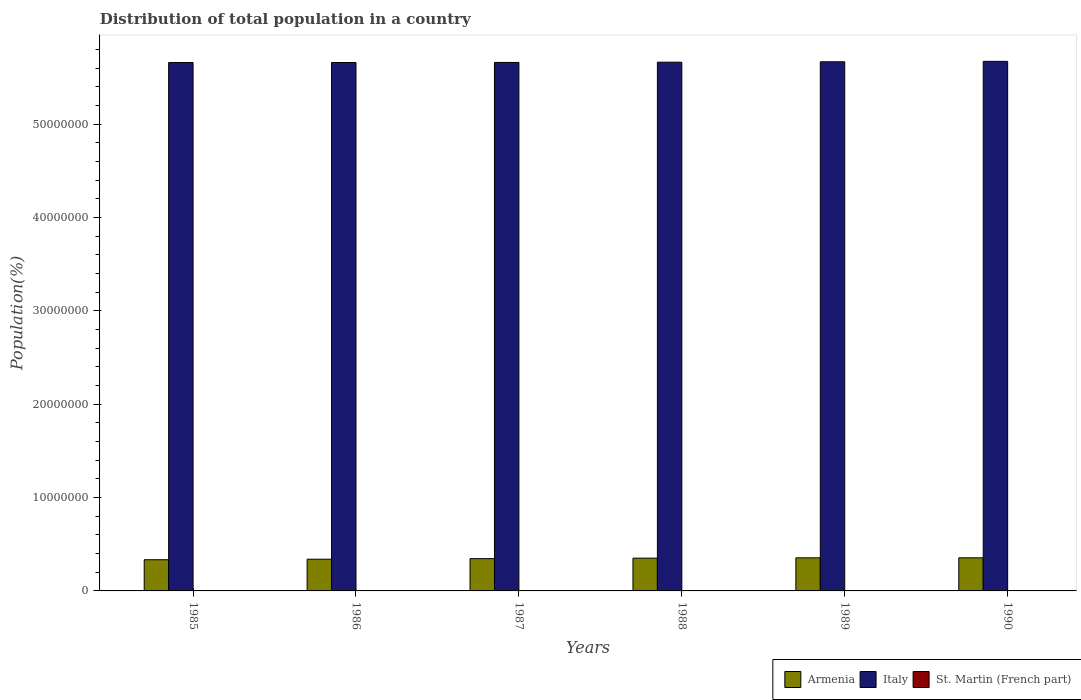How many bars are there on the 3rd tick from the left?
Provide a short and direct response. 3. What is the population of in Italy in 1987?
Ensure brevity in your answer.  5.66e+07. Across all years, what is the maximum population of in St. Martin (French part)?
Give a very brief answer. 3.00e+04. Across all years, what is the minimum population of in Italy?
Make the answer very short. 5.66e+07. What is the total population of in Italy in the graph?
Give a very brief answer. 3.40e+08. What is the difference between the population of in Italy in 1986 and that in 1990?
Provide a short and direct response. -1.23e+05. What is the difference between the population of in St. Martin (French part) in 1988 and the population of in Armenia in 1990?
Provide a short and direct response. -3.52e+06. What is the average population of in St. Martin (French part) per year?
Offer a very short reply. 2.30e+04. In the year 1990, what is the difference between the population of in Italy and population of in St. Martin (French part)?
Keep it short and to the point. 5.67e+07. What is the ratio of the population of in Italy in 1985 to that in 1986?
Make the answer very short. 1. Is the difference between the population of in Italy in 1985 and 1989 greater than the difference between the population of in St. Martin (French part) in 1985 and 1989?
Give a very brief answer. No. What is the difference between the highest and the second highest population of in St. Martin (French part)?
Your answer should be very brief. 2360. What is the difference between the highest and the lowest population of in St. Martin (French part)?
Your answer should be compact. 1.46e+04. Is the sum of the population of in Armenia in 1988 and 1989 greater than the maximum population of in Italy across all years?
Your answer should be very brief. No. What does the 3rd bar from the left in 1985 represents?
Your answer should be compact. St. Martin (French part). What does the 1st bar from the right in 1988 represents?
Your response must be concise. St. Martin (French part). Is it the case that in every year, the sum of the population of in Armenia and population of in Italy is greater than the population of in St. Martin (French part)?
Offer a very short reply. Yes. How many bars are there?
Give a very brief answer. 18. Are all the bars in the graph horizontal?
Provide a succinct answer. No. What is the difference between two consecutive major ticks on the Y-axis?
Keep it short and to the point. 1.00e+07. How many legend labels are there?
Provide a succinct answer. 3. What is the title of the graph?
Your response must be concise. Distribution of total population in a country. What is the label or title of the Y-axis?
Your answer should be very brief. Population(%). What is the Population(%) of Armenia in 1985?
Provide a short and direct response. 3.34e+06. What is the Population(%) in Italy in 1985?
Keep it short and to the point. 5.66e+07. What is the Population(%) of St. Martin (French part) in 1985?
Ensure brevity in your answer.  1.54e+04. What is the Population(%) in Armenia in 1986?
Provide a short and direct response. 3.40e+06. What is the Population(%) of Italy in 1986?
Keep it short and to the point. 5.66e+07. What is the Population(%) of St. Martin (French part) in 1986?
Offer a terse response. 1.83e+04. What is the Population(%) in Armenia in 1987?
Keep it short and to the point. 3.46e+06. What is the Population(%) in Italy in 1987?
Keep it short and to the point. 5.66e+07. What is the Population(%) of St. Martin (French part) in 1987?
Make the answer very short. 2.16e+04. What is the Population(%) of Armenia in 1988?
Your answer should be compact. 3.51e+06. What is the Population(%) of Italy in 1988?
Provide a short and direct response. 5.66e+07. What is the Population(%) of St. Martin (French part) in 1988?
Provide a succinct answer. 2.49e+04. What is the Population(%) of Armenia in 1989?
Offer a terse response. 3.54e+06. What is the Population(%) in Italy in 1989?
Your answer should be compact. 5.67e+07. What is the Population(%) of St. Martin (French part) in 1989?
Give a very brief answer. 2.77e+04. What is the Population(%) of Armenia in 1990?
Offer a very short reply. 3.54e+06. What is the Population(%) of Italy in 1990?
Offer a very short reply. 5.67e+07. What is the Population(%) of St. Martin (French part) in 1990?
Your answer should be very brief. 3.00e+04. Across all years, what is the maximum Population(%) in Armenia?
Give a very brief answer. 3.54e+06. Across all years, what is the maximum Population(%) in Italy?
Your response must be concise. 5.67e+07. Across all years, what is the maximum Population(%) in St. Martin (French part)?
Give a very brief answer. 3.00e+04. Across all years, what is the minimum Population(%) of Armenia?
Your answer should be very brief. 3.34e+06. Across all years, what is the minimum Population(%) in Italy?
Your answer should be compact. 5.66e+07. Across all years, what is the minimum Population(%) in St. Martin (French part)?
Your answer should be compact. 1.54e+04. What is the total Population(%) of Armenia in the graph?
Keep it short and to the point. 2.08e+07. What is the total Population(%) of Italy in the graph?
Offer a terse response. 3.40e+08. What is the total Population(%) in St. Martin (French part) in the graph?
Ensure brevity in your answer.  1.38e+05. What is the difference between the Population(%) in Armenia in 1985 and that in 1986?
Keep it short and to the point. -5.74e+04. What is the difference between the Population(%) of Italy in 1985 and that in 1986?
Offer a very short reply. -3084. What is the difference between the Population(%) in St. Martin (French part) in 1985 and that in 1986?
Your response must be concise. -2945. What is the difference between the Population(%) of Armenia in 1985 and that in 1987?
Offer a very short reply. -1.18e+05. What is the difference between the Population(%) of Italy in 1985 and that in 1987?
Give a very brief answer. -8860. What is the difference between the Population(%) of St. Martin (French part) in 1985 and that in 1987?
Offer a very short reply. -6236. What is the difference between the Population(%) of Armenia in 1985 and that in 1988?
Provide a succinct answer. -1.71e+05. What is the difference between the Population(%) in Italy in 1985 and that in 1988?
Ensure brevity in your answer.  -3.62e+04. What is the difference between the Population(%) in St. Martin (French part) in 1985 and that in 1988?
Your response must be concise. -9481. What is the difference between the Population(%) in Armenia in 1985 and that in 1989?
Ensure brevity in your answer.  -2.04e+05. What is the difference between the Population(%) of Italy in 1985 and that in 1989?
Offer a very short reply. -7.87e+04. What is the difference between the Population(%) of St. Martin (French part) in 1985 and that in 1989?
Your answer should be very brief. -1.23e+04. What is the difference between the Population(%) of Armenia in 1985 and that in 1990?
Your response must be concise. -2.06e+05. What is the difference between the Population(%) in Italy in 1985 and that in 1990?
Offer a terse response. -1.26e+05. What is the difference between the Population(%) in St. Martin (French part) in 1985 and that in 1990?
Offer a very short reply. -1.46e+04. What is the difference between the Population(%) in Armenia in 1986 and that in 1987?
Offer a very short reply. -6.05e+04. What is the difference between the Population(%) in Italy in 1986 and that in 1987?
Provide a short and direct response. -5776. What is the difference between the Population(%) of St. Martin (French part) in 1986 and that in 1987?
Your answer should be compact. -3291. What is the difference between the Population(%) of Armenia in 1986 and that in 1988?
Your answer should be very brief. -1.14e+05. What is the difference between the Population(%) in Italy in 1986 and that in 1988?
Offer a terse response. -3.31e+04. What is the difference between the Population(%) in St. Martin (French part) in 1986 and that in 1988?
Your answer should be compact. -6536. What is the difference between the Population(%) of Armenia in 1986 and that in 1989?
Your answer should be compact. -1.46e+05. What is the difference between the Population(%) in Italy in 1986 and that in 1989?
Give a very brief answer. -7.56e+04. What is the difference between the Population(%) in St. Martin (French part) in 1986 and that in 1989?
Offer a terse response. -9339. What is the difference between the Population(%) of Armenia in 1986 and that in 1990?
Provide a succinct answer. -1.48e+05. What is the difference between the Population(%) of Italy in 1986 and that in 1990?
Ensure brevity in your answer.  -1.23e+05. What is the difference between the Population(%) in St. Martin (French part) in 1986 and that in 1990?
Offer a very short reply. -1.17e+04. What is the difference between the Population(%) of Armenia in 1987 and that in 1988?
Offer a terse response. -5.34e+04. What is the difference between the Population(%) of Italy in 1987 and that in 1988?
Your response must be concise. -2.74e+04. What is the difference between the Population(%) in St. Martin (French part) in 1987 and that in 1988?
Your answer should be compact. -3245. What is the difference between the Population(%) of Armenia in 1987 and that in 1989?
Your response must be concise. -8.57e+04. What is the difference between the Population(%) of Italy in 1987 and that in 1989?
Offer a terse response. -6.98e+04. What is the difference between the Population(%) in St. Martin (French part) in 1987 and that in 1989?
Offer a terse response. -6048. What is the difference between the Population(%) in Armenia in 1987 and that in 1990?
Provide a succinct answer. -8.76e+04. What is the difference between the Population(%) of Italy in 1987 and that in 1990?
Give a very brief answer. -1.17e+05. What is the difference between the Population(%) of St. Martin (French part) in 1987 and that in 1990?
Keep it short and to the point. -8408. What is the difference between the Population(%) of Armenia in 1988 and that in 1989?
Ensure brevity in your answer.  -3.23e+04. What is the difference between the Population(%) in Italy in 1988 and that in 1989?
Offer a very short reply. -4.25e+04. What is the difference between the Population(%) of St. Martin (French part) in 1988 and that in 1989?
Give a very brief answer. -2803. What is the difference between the Population(%) of Armenia in 1988 and that in 1990?
Give a very brief answer. -3.43e+04. What is the difference between the Population(%) in Italy in 1988 and that in 1990?
Your response must be concise. -9.00e+04. What is the difference between the Population(%) in St. Martin (French part) in 1988 and that in 1990?
Your response must be concise. -5163. What is the difference between the Population(%) of Armenia in 1989 and that in 1990?
Give a very brief answer. -1975. What is the difference between the Population(%) in Italy in 1989 and that in 1990?
Keep it short and to the point. -4.75e+04. What is the difference between the Population(%) of St. Martin (French part) in 1989 and that in 1990?
Ensure brevity in your answer.  -2360. What is the difference between the Population(%) in Armenia in 1985 and the Population(%) in Italy in 1986?
Ensure brevity in your answer.  -5.33e+07. What is the difference between the Population(%) in Armenia in 1985 and the Population(%) in St. Martin (French part) in 1986?
Your answer should be very brief. 3.32e+06. What is the difference between the Population(%) of Italy in 1985 and the Population(%) of St. Martin (French part) in 1986?
Offer a terse response. 5.66e+07. What is the difference between the Population(%) of Armenia in 1985 and the Population(%) of Italy in 1987?
Provide a short and direct response. -5.33e+07. What is the difference between the Population(%) of Armenia in 1985 and the Population(%) of St. Martin (French part) in 1987?
Give a very brief answer. 3.32e+06. What is the difference between the Population(%) in Italy in 1985 and the Population(%) in St. Martin (French part) in 1987?
Your response must be concise. 5.66e+07. What is the difference between the Population(%) in Armenia in 1985 and the Population(%) in Italy in 1988?
Offer a terse response. -5.33e+07. What is the difference between the Population(%) in Armenia in 1985 and the Population(%) in St. Martin (French part) in 1988?
Provide a short and direct response. 3.31e+06. What is the difference between the Population(%) in Italy in 1985 and the Population(%) in St. Martin (French part) in 1988?
Your answer should be compact. 5.66e+07. What is the difference between the Population(%) of Armenia in 1985 and the Population(%) of Italy in 1989?
Keep it short and to the point. -5.33e+07. What is the difference between the Population(%) of Armenia in 1985 and the Population(%) of St. Martin (French part) in 1989?
Your answer should be compact. 3.31e+06. What is the difference between the Population(%) of Italy in 1985 and the Population(%) of St. Martin (French part) in 1989?
Provide a short and direct response. 5.66e+07. What is the difference between the Population(%) in Armenia in 1985 and the Population(%) in Italy in 1990?
Your answer should be very brief. -5.34e+07. What is the difference between the Population(%) in Armenia in 1985 and the Population(%) in St. Martin (French part) in 1990?
Offer a very short reply. 3.31e+06. What is the difference between the Population(%) in Italy in 1985 and the Population(%) in St. Martin (French part) in 1990?
Keep it short and to the point. 5.66e+07. What is the difference between the Population(%) of Armenia in 1986 and the Population(%) of Italy in 1987?
Offer a very short reply. -5.32e+07. What is the difference between the Population(%) in Armenia in 1986 and the Population(%) in St. Martin (French part) in 1987?
Give a very brief answer. 3.37e+06. What is the difference between the Population(%) in Italy in 1986 and the Population(%) in St. Martin (French part) in 1987?
Your answer should be very brief. 5.66e+07. What is the difference between the Population(%) of Armenia in 1986 and the Population(%) of Italy in 1988?
Make the answer very short. -5.32e+07. What is the difference between the Population(%) of Armenia in 1986 and the Population(%) of St. Martin (French part) in 1988?
Give a very brief answer. 3.37e+06. What is the difference between the Population(%) in Italy in 1986 and the Population(%) in St. Martin (French part) in 1988?
Your answer should be compact. 5.66e+07. What is the difference between the Population(%) in Armenia in 1986 and the Population(%) in Italy in 1989?
Ensure brevity in your answer.  -5.33e+07. What is the difference between the Population(%) in Armenia in 1986 and the Population(%) in St. Martin (French part) in 1989?
Provide a short and direct response. 3.37e+06. What is the difference between the Population(%) of Italy in 1986 and the Population(%) of St. Martin (French part) in 1989?
Your response must be concise. 5.66e+07. What is the difference between the Population(%) of Armenia in 1986 and the Population(%) of Italy in 1990?
Give a very brief answer. -5.33e+07. What is the difference between the Population(%) of Armenia in 1986 and the Population(%) of St. Martin (French part) in 1990?
Keep it short and to the point. 3.37e+06. What is the difference between the Population(%) in Italy in 1986 and the Population(%) in St. Martin (French part) in 1990?
Give a very brief answer. 5.66e+07. What is the difference between the Population(%) in Armenia in 1987 and the Population(%) in Italy in 1988?
Provide a succinct answer. -5.32e+07. What is the difference between the Population(%) in Armenia in 1987 and the Population(%) in St. Martin (French part) in 1988?
Ensure brevity in your answer.  3.43e+06. What is the difference between the Population(%) in Italy in 1987 and the Population(%) in St. Martin (French part) in 1988?
Provide a succinct answer. 5.66e+07. What is the difference between the Population(%) in Armenia in 1987 and the Population(%) in Italy in 1989?
Provide a short and direct response. -5.32e+07. What is the difference between the Population(%) in Armenia in 1987 and the Population(%) in St. Martin (French part) in 1989?
Offer a terse response. 3.43e+06. What is the difference between the Population(%) in Italy in 1987 and the Population(%) in St. Martin (French part) in 1989?
Give a very brief answer. 5.66e+07. What is the difference between the Population(%) in Armenia in 1987 and the Population(%) in Italy in 1990?
Make the answer very short. -5.33e+07. What is the difference between the Population(%) in Armenia in 1987 and the Population(%) in St. Martin (French part) in 1990?
Give a very brief answer. 3.43e+06. What is the difference between the Population(%) in Italy in 1987 and the Population(%) in St. Martin (French part) in 1990?
Offer a very short reply. 5.66e+07. What is the difference between the Population(%) in Armenia in 1988 and the Population(%) in Italy in 1989?
Provide a succinct answer. -5.32e+07. What is the difference between the Population(%) of Armenia in 1988 and the Population(%) of St. Martin (French part) in 1989?
Make the answer very short. 3.48e+06. What is the difference between the Population(%) of Italy in 1988 and the Population(%) of St. Martin (French part) in 1989?
Offer a very short reply. 5.66e+07. What is the difference between the Population(%) in Armenia in 1988 and the Population(%) in Italy in 1990?
Offer a very short reply. -5.32e+07. What is the difference between the Population(%) of Armenia in 1988 and the Population(%) of St. Martin (French part) in 1990?
Make the answer very short. 3.48e+06. What is the difference between the Population(%) of Italy in 1988 and the Population(%) of St. Martin (French part) in 1990?
Offer a very short reply. 5.66e+07. What is the difference between the Population(%) in Armenia in 1989 and the Population(%) in Italy in 1990?
Offer a terse response. -5.32e+07. What is the difference between the Population(%) in Armenia in 1989 and the Population(%) in St. Martin (French part) in 1990?
Your response must be concise. 3.51e+06. What is the difference between the Population(%) in Italy in 1989 and the Population(%) in St. Martin (French part) in 1990?
Provide a succinct answer. 5.66e+07. What is the average Population(%) in Armenia per year?
Your response must be concise. 3.47e+06. What is the average Population(%) of Italy per year?
Your answer should be very brief. 5.66e+07. What is the average Population(%) in St. Martin (French part) per year?
Your response must be concise. 2.30e+04. In the year 1985, what is the difference between the Population(%) in Armenia and Population(%) in Italy?
Give a very brief answer. -5.33e+07. In the year 1985, what is the difference between the Population(%) in Armenia and Population(%) in St. Martin (French part)?
Make the answer very short. 3.32e+06. In the year 1985, what is the difference between the Population(%) in Italy and Population(%) in St. Martin (French part)?
Offer a very short reply. 5.66e+07. In the year 1986, what is the difference between the Population(%) of Armenia and Population(%) of Italy?
Provide a succinct answer. -5.32e+07. In the year 1986, what is the difference between the Population(%) of Armenia and Population(%) of St. Martin (French part)?
Your response must be concise. 3.38e+06. In the year 1986, what is the difference between the Population(%) of Italy and Population(%) of St. Martin (French part)?
Provide a succinct answer. 5.66e+07. In the year 1987, what is the difference between the Population(%) of Armenia and Population(%) of Italy?
Provide a short and direct response. -5.31e+07. In the year 1987, what is the difference between the Population(%) of Armenia and Population(%) of St. Martin (French part)?
Provide a succinct answer. 3.44e+06. In the year 1987, what is the difference between the Population(%) in Italy and Population(%) in St. Martin (French part)?
Give a very brief answer. 5.66e+07. In the year 1988, what is the difference between the Population(%) of Armenia and Population(%) of Italy?
Your answer should be compact. -5.31e+07. In the year 1988, what is the difference between the Population(%) of Armenia and Population(%) of St. Martin (French part)?
Provide a short and direct response. 3.49e+06. In the year 1988, what is the difference between the Population(%) of Italy and Population(%) of St. Martin (French part)?
Offer a terse response. 5.66e+07. In the year 1989, what is the difference between the Population(%) of Armenia and Population(%) of Italy?
Your answer should be very brief. -5.31e+07. In the year 1989, what is the difference between the Population(%) in Armenia and Population(%) in St. Martin (French part)?
Your answer should be compact. 3.52e+06. In the year 1989, what is the difference between the Population(%) of Italy and Population(%) of St. Martin (French part)?
Provide a succinct answer. 5.66e+07. In the year 1990, what is the difference between the Population(%) of Armenia and Population(%) of Italy?
Make the answer very short. -5.32e+07. In the year 1990, what is the difference between the Population(%) of Armenia and Population(%) of St. Martin (French part)?
Keep it short and to the point. 3.51e+06. In the year 1990, what is the difference between the Population(%) in Italy and Population(%) in St. Martin (French part)?
Ensure brevity in your answer.  5.67e+07. What is the ratio of the Population(%) in Armenia in 1985 to that in 1986?
Offer a terse response. 0.98. What is the ratio of the Population(%) in St. Martin (French part) in 1985 to that in 1986?
Offer a very short reply. 0.84. What is the ratio of the Population(%) in Armenia in 1985 to that in 1987?
Your answer should be very brief. 0.97. What is the ratio of the Population(%) of St. Martin (French part) in 1985 to that in 1987?
Your answer should be compact. 0.71. What is the ratio of the Population(%) in Armenia in 1985 to that in 1988?
Ensure brevity in your answer.  0.95. What is the ratio of the Population(%) of Italy in 1985 to that in 1988?
Your answer should be very brief. 1. What is the ratio of the Population(%) in St. Martin (French part) in 1985 to that in 1988?
Provide a succinct answer. 0.62. What is the ratio of the Population(%) of Armenia in 1985 to that in 1989?
Ensure brevity in your answer.  0.94. What is the ratio of the Population(%) in St. Martin (French part) in 1985 to that in 1989?
Your answer should be compact. 0.56. What is the ratio of the Population(%) of Armenia in 1985 to that in 1990?
Provide a succinct answer. 0.94. What is the ratio of the Population(%) of St. Martin (French part) in 1985 to that in 1990?
Offer a terse response. 0.51. What is the ratio of the Population(%) of Armenia in 1986 to that in 1987?
Provide a short and direct response. 0.98. What is the ratio of the Population(%) of Italy in 1986 to that in 1987?
Ensure brevity in your answer.  1. What is the ratio of the Population(%) in St. Martin (French part) in 1986 to that in 1987?
Ensure brevity in your answer.  0.85. What is the ratio of the Population(%) in Armenia in 1986 to that in 1988?
Keep it short and to the point. 0.97. What is the ratio of the Population(%) of Italy in 1986 to that in 1988?
Give a very brief answer. 1. What is the ratio of the Population(%) of St. Martin (French part) in 1986 to that in 1988?
Your answer should be compact. 0.74. What is the ratio of the Population(%) of Armenia in 1986 to that in 1989?
Ensure brevity in your answer.  0.96. What is the ratio of the Population(%) in St. Martin (French part) in 1986 to that in 1989?
Your answer should be very brief. 0.66. What is the ratio of the Population(%) of Armenia in 1986 to that in 1990?
Offer a very short reply. 0.96. What is the ratio of the Population(%) of St. Martin (French part) in 1986 to that in 1990?
Keep it short and to the point. 0.61. What is the ratio of the Population(%) in Italy in 1987 to that in 1988?
Your response must be concise. 1. What is the ratio of the Population(%) of St. Martin (French part) in 1987 to that in 1988?
Your answer should be very brief. 0.87. What is the ratio of the Population(%) in Armenia in 1987 to that in 1989?
Provide a succinct answer. 0.98. What is the ratio of the Population(%) of St. Martin (French part) in 1987 to that in 1989?
Your answer should be compact. 0.78. What is the ratio of the Population(%) of Armenia in 1987 to that in 1990?
Provide a short and direct response. 0.98. What is the ratio of the Population(%) in Italy in 1987 to that in 1990?
Ensure brevity in your answer.  1. What is the ratio of the Population(%) in St. Martin (French part) in 1987 to that in 1990?
Make the answer very short. 0.72. What is the ratio of the Population(%) in Armenia in 1988 to that in 1989?
Your answer should be very brief. 0.99. What is the ratio of the Population(%) in Italy in 1988 to that in 1989?
Keep it short and to the point. 1. What is the ratio of the Population(%) in St. Martin (French part) in 1988 to that in 1989?
Offer a very short reply. 0.9. What is the ratio of the Population(%) in Armenia in 1988 to that in 1990?
Provide a succinct answer. 0.99. What is the ratio of the Population(%) of Italy in 1988 to that in 1990?
Your response must be concise. 1. What is the ratio of the Population(%) in St. Martin (French part) in 1988 to that in 1990?
Provide a succinct answer. 0.83. What is the ratio of the Population(%) of Armenia in 1989 to that in 1990?
Your answer should be very brief. 1. What is the ratio of the Population(%) of Italy in 1989 to that in 1990?
Provide a short and direct response. 1. What is the ratio of the Population(%) of St. Martin (French part) in 1989 to that in 1990?
Your response must be concise. 0.92. What is the difference between the highest and the second highest Population(%) in Armenia?
Make the answer very short. 1975. What is the difference between the highest and the second highest Population(%) of Italy?
Your response must be concise. 4.75e+04. What is the difference between the highest and the second highest Population(%) in St. Martin (French part)?
Offer a very short reply. 2360. What is the difference between the highest and the lowest Population(%) of Armenia?
Keep it short and to the point. 2.06e+05. What is the difference between the highest and the lowest Population(%) in Italy?
Offer a very short reply. 1.26e+05. What is the difference between the highest and the lowest Population(%) of St. Martin (French part)?
Give a very brief answer. 1.46e+04. 